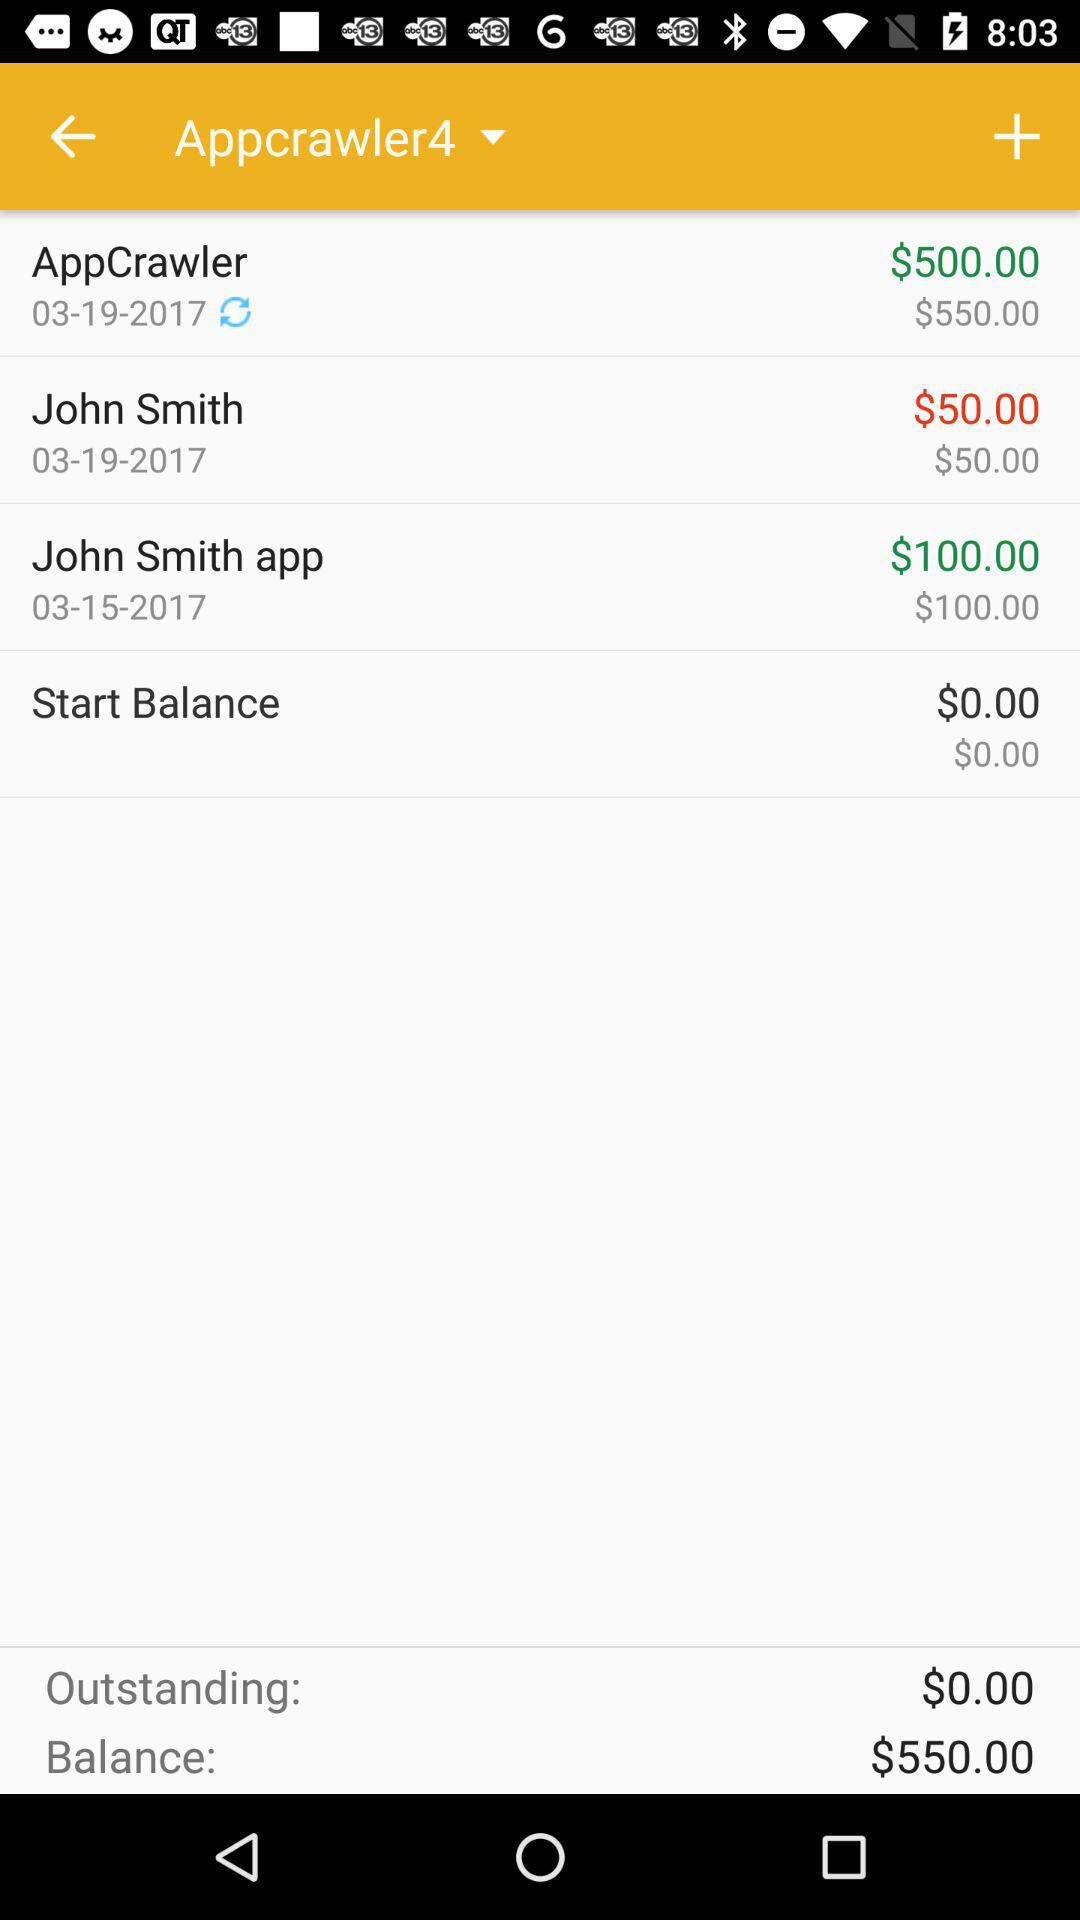What's the balance after paying John Smith on 19th March 2017? The balance is $50. 